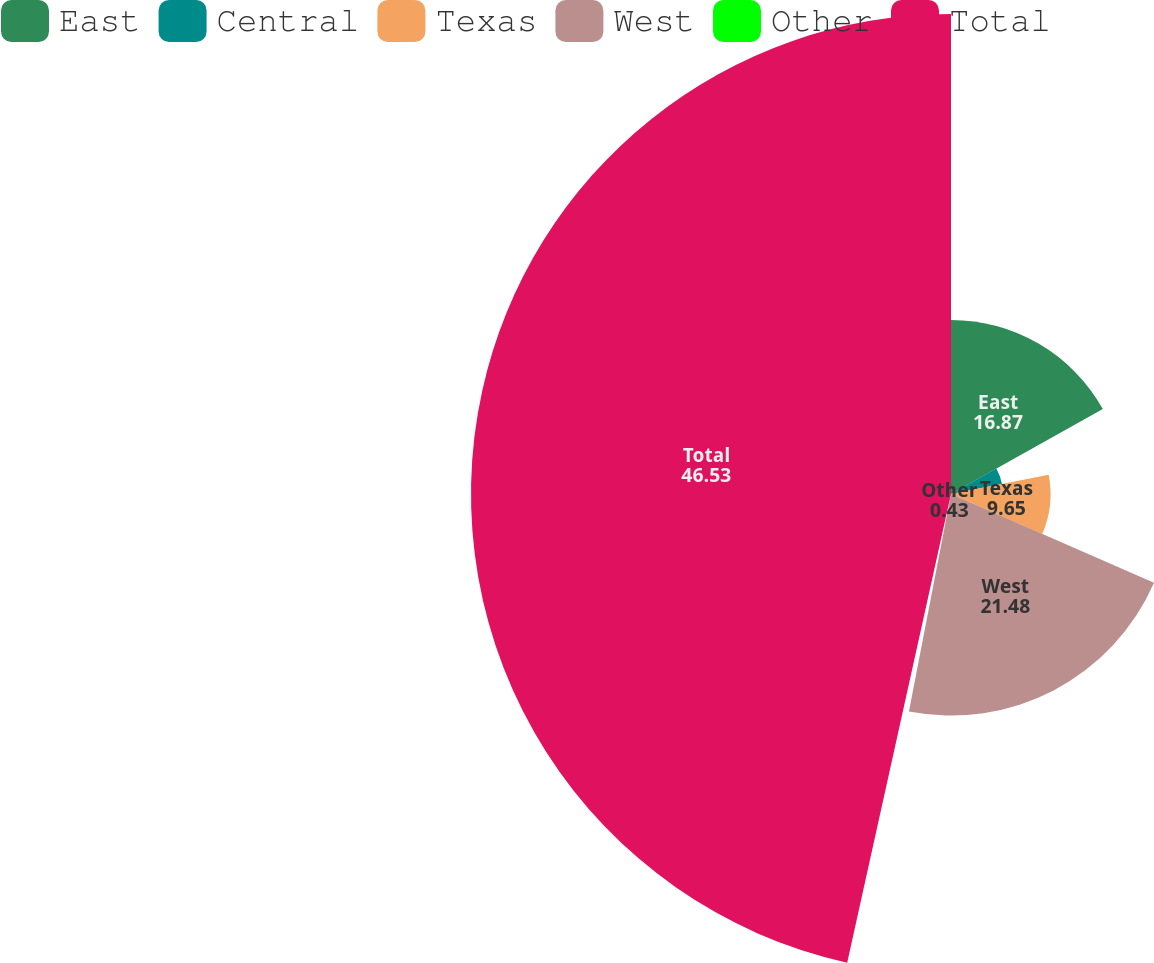Convert chart to OTSL. <chart><loc_0><loc_0><loc_500><loc_500><pie_chart><fcel>East<fcel>Central<fcel>Texas<fcel>West<fcel>Other<fcel>Total<nl><fcel>16.87%<fcel>5.04%<fcel>9.65%<fcel>21.48%<fcel>0.43%<fcel>46.53%<nl></chart> 